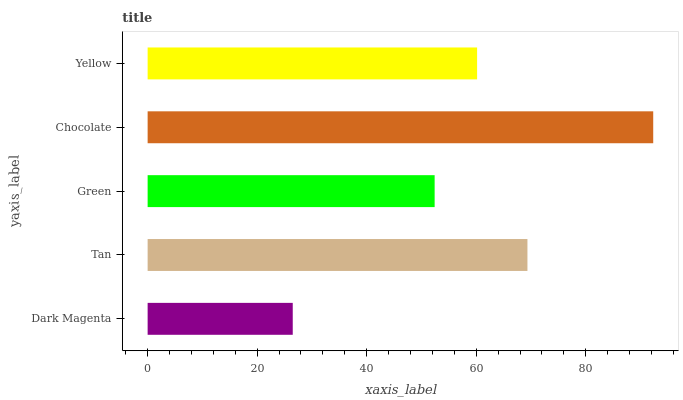Is Dark Magenta the minimum?
Answer yes or no. Yes. Is Chocolate the maximum?
Answer yes or no. Yes. Is Tan the minimum?
Answer yes or no. No. Is Tan the maximum?
Answer yes or no. No. Is Tan greater than Dark Magenta?
Answer yes or no. Yes. Is Dark Magenta less than Tan?
Answer yes or no. Yes. Is Dark Magenta greater than Tan?
Answer yes or no. No. Is Tan less than Dark Magenta?
Answer yes or no. No. Is Yellow the high median?
Answer yes or no. Yes. Is Yellow the low median?
Answer yes or no. Yes. Is Green the high median?
Answer yes or no. No. Is Dark Magenta the low median?
Answer yes or no. No. 